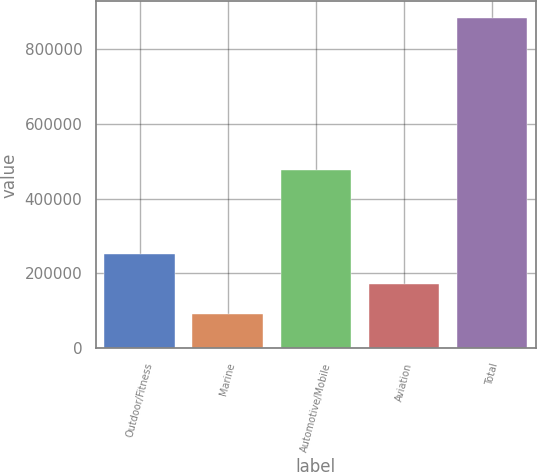<chart> <loc_0><loc_0><loc_500><loc_500><bar_chart><fcel>Outdoor/Fitness<fcel>Marine<fcel>Automotive/Mobile<fcel>Aviation<fcel>Total<nl><fcel>250839<fcel>92952<fcel>475191<fcel>171895<fcel>882386<nl></chart> 